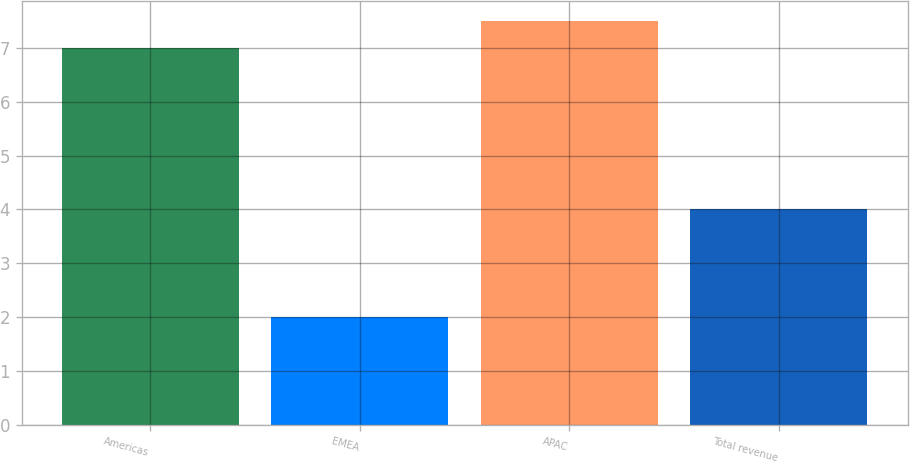Convert chart to OTSL. <chart><loc_0><loc_0><loc_500><loc_500><bar_chart><fcel>Americas<fcel>EMEA<fcel>APAC<fcel>Total revenue<nl><fcel>7<fcel>2<fcel>7.5<fcel>4<nl></chart> 